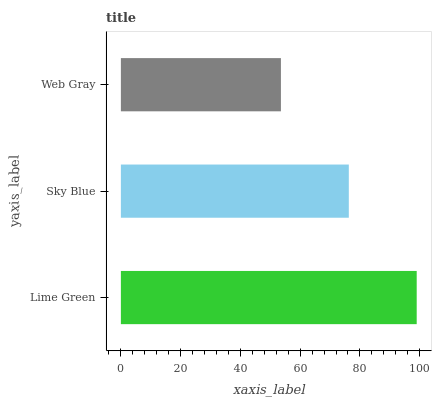Is Web Gray the minimum?
Answer yes or no. Yes. Is Lime Green the maximum?
Answer yes or no. Yes. Is Sky Blue the minimum?
Answer yes or no. No. Is Sky Blue the maximum?
Answer yes or no. No. Is Lime Green greater than Sky Blue?
Answer yes or no. Yes. Is Sky Blue less than Lime Green?
Answer yes or no. Yes. Is Sky Blue greater than Lime Green?
Answer yes or no. No. Is Lime Green less than Sky Blue?
Answer yes or no. No. Is Sky Blue the high median?
Answer yes or no. Yes. Is Sky Blue the low median?
Answer yes or no. Yes. Is Lime Green the high median?
Answer yes or no. No. Is Lime Green the low median?
Answer yes or no. No. 